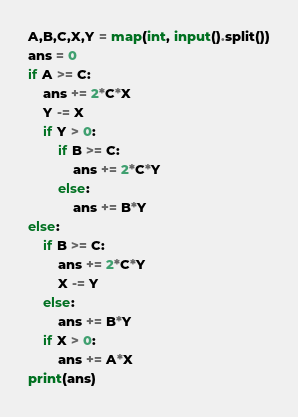Convert code to text. <code><loc_0><loc_0><loc_500><loc_500><_Python_>A,B,C,X,Y = map(int, input().split())
ans = 0
if A >= C:
    ans += 2*C*X
    Y -= X
    if Y > 0:
        if B >= C:
            ans += 2*C*Y
        else:
            ans += B*Y
else:
    if B >= C:
        ans += 2*C*Y
        X -= Y
    else:
        ans += B*Y
    if X > 0:
        ans += A*X
print(ans)</code> 